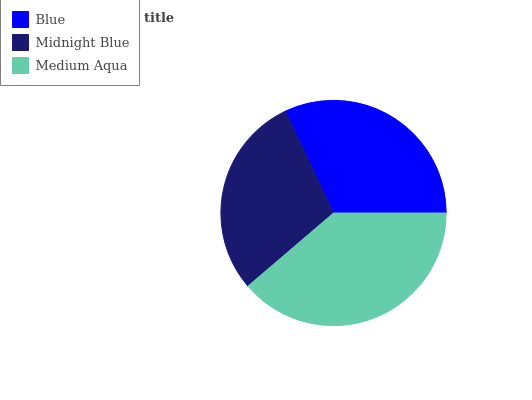Is Midnight Blue the minimum?
Answer yes or no. Yes. Is Medium Aqua the maximum?
Answer yes or no. Yes. Is Medium Aqua the minimum?
Answer yes or no. No. Is Midnight Blue the maximum?
Answer yes or no. No. Is Medium Aqua greater than Midnight Blue?
Answer yes or no. Yes. Is Midnight Blue less than Medium Aqua?
Answer yes or no. Yes. Is Midnight Blue greater than Medium Aqua?
Answer yes or no. No. Is Medium Aqua less than Midnight Blue?
Answer yes or no. No. Is Blue the high median?
Answer yes or no. Yes. Is Blue the low median?
Answer yes or no. Yes. Is Medium Aqua the high median?
Answer yes or no. No. Is Midnight Blue the low median?
Answer yes or no. No. 